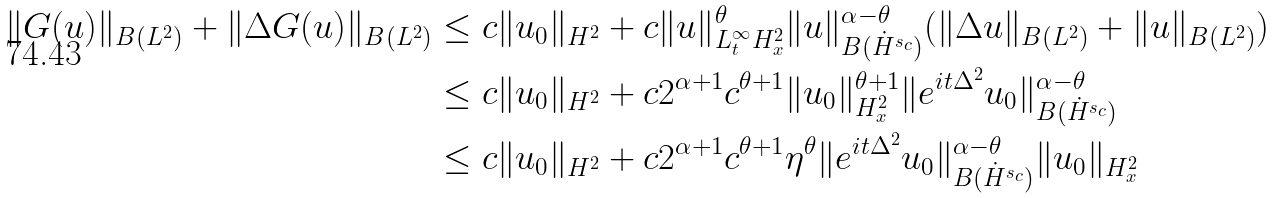Convert formula to latex. <formula><loc_0><loc_0><loc_500><loc_500>\| G ( u ) \| _ { B ( L ^ { 2 } ) } + \| \Delta G ( u ) \| _ { B ( L ^ { 2 } ) } & \leq c \| u _ { 0 } \| _ { H ^ { 2 } } + c \| u \| ^ { \theta } _ { L ^ { \infty } _ { t } H ^ { 2 } _ { x } } \| u \| ^ { \alpha - \theta } _ { B ( \dot { H } ^ { s _ { c } } ) } ( \| \Delta u \| _ { B ( L ^ { 2 } ) } + \| u \| _ { B ( L ^ { 2 } ) } ) \\ & \leq c \| u _ { 0 } \| _ { H ^ { 2 } } + c 2 ^ { \alpha + 1 } c ^ { \theta + 1 } \| u _ { 0 } \| _ { H ^ { 2 } _ { x } } ^ { \theta + 1 } \| e ^ { i t \Delta ^ { 2 } } u _ { 0 } \| ^ { \alpha - \theta } _ { B ( \dot { H } ^ { s _ { c } } ) } \\ & \leq c \| u _ { 0 } \| _ { H ^ { 2 } } + c 2 ^ { \alpha + 1 } c ^ { \theta + 1 } \eta ^ { \theta } \| e ^ { i t \Delta ^ { 2 } } u _ { 0 } \| ^ { \alpha - \theta } _ { B ( \dot { H } ^ { s _ { c } } ) } \| u _ { 0 } \| _ { H ^ { 2 } _ { x } }</formula> 